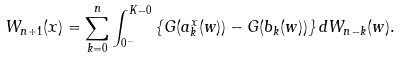Convert formula to latex. <formula><loc_0><loc_0><loc_500><loc_500>W _ { n + 1 } ( x ) = \sum _ { k = 0 } ^ { n } \int _ { 0 ^ { - } } ^ { K - 0 } \left \{ G ( a _ { k } ^ { x } ( w ) ) - G ( b _ { k } ( w ) ) \right \} d W _ { n - k } ( w ) .</formula> 